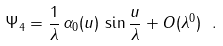<formula> <loc_0><loc_0><loc_500><loc_500>\Psi _ { 4 } = \frac { 1 } { \lambda } \, \alpha _ { 0 } ( u ) \, \sin \frac { u } { \lambda } + O ( \lambda ^ { 0 } ) \ .</formula> 